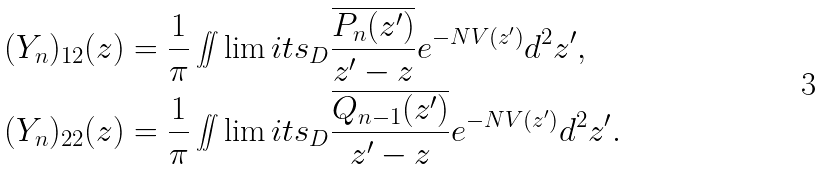<formula> <loc_0><loc_0><loc_500><loc_500>( Y _ { n } ) _ { 1 2 } ( z ) & = \frac { 1 } { \pi } \iint \lim i t s _ { D } \frac { \overline { P _ { n } ( z ^ { \prime } ) } } { z ^ { \prime } - z } e ^ { - N V ( z ^ { \prime } ) } d ^ { 2 } z ^ { \prime } , \\ ( Y _ { n } ) _ { 2 2 } ( z ) & = \frac { 1 } { \pi } \iint \lim i t s _ { D } \frac { \overline { Q _ { n - 1 } ( z ^ { \prime } ) } } { z ^ { \prime } - z } e ^ { - N V ( z ^ { \prime } ) } d ^ { 2 } z ^ { \prime } .</formula> 